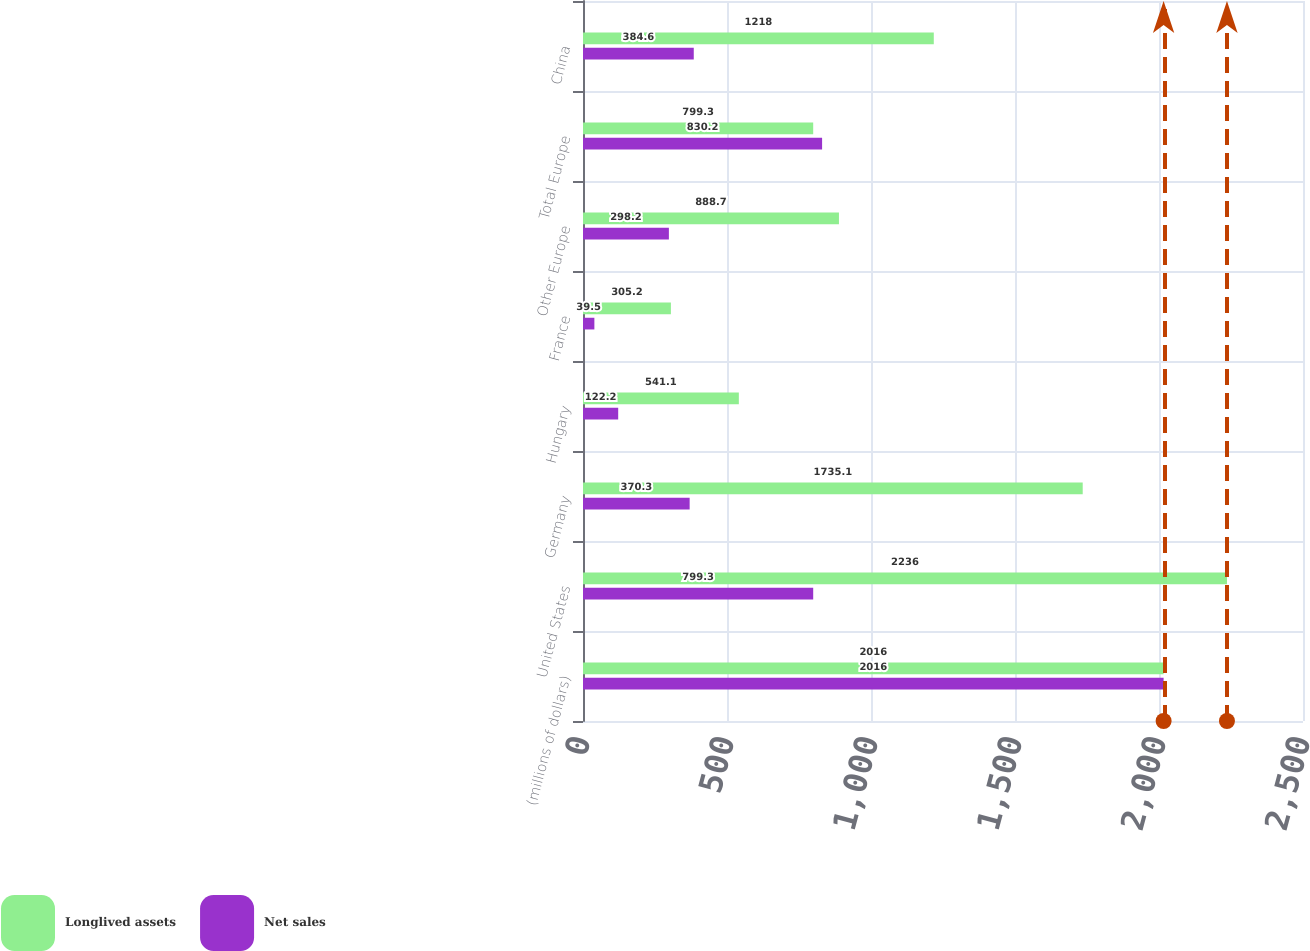Convert chart to OTSL. <chart><loc_0><loc_0><loc_500><loc_500><stacked_bar_chart><ecel><fcel>(millions of dollars)<fcel>United States<fcel>Germany<fcel>Hungary<fcel>France<fcel>Other Europe<fcel>Total Europe<fcel>China<nl><fcel>Longlived assets<fcel>2016<fcel>2236<fcel>1735.1<fcel>541.1<fcel>305.2<fcel>888.7<fcel>799.3<fcel>1218<nl><fcel>Net sales<fcel>2016<fcel>799.3<fcel>370.3<fcel>122.2<fcel>39.5<fcel>298.2<fcel>830.2<fcel>384.6<nl></chart> 